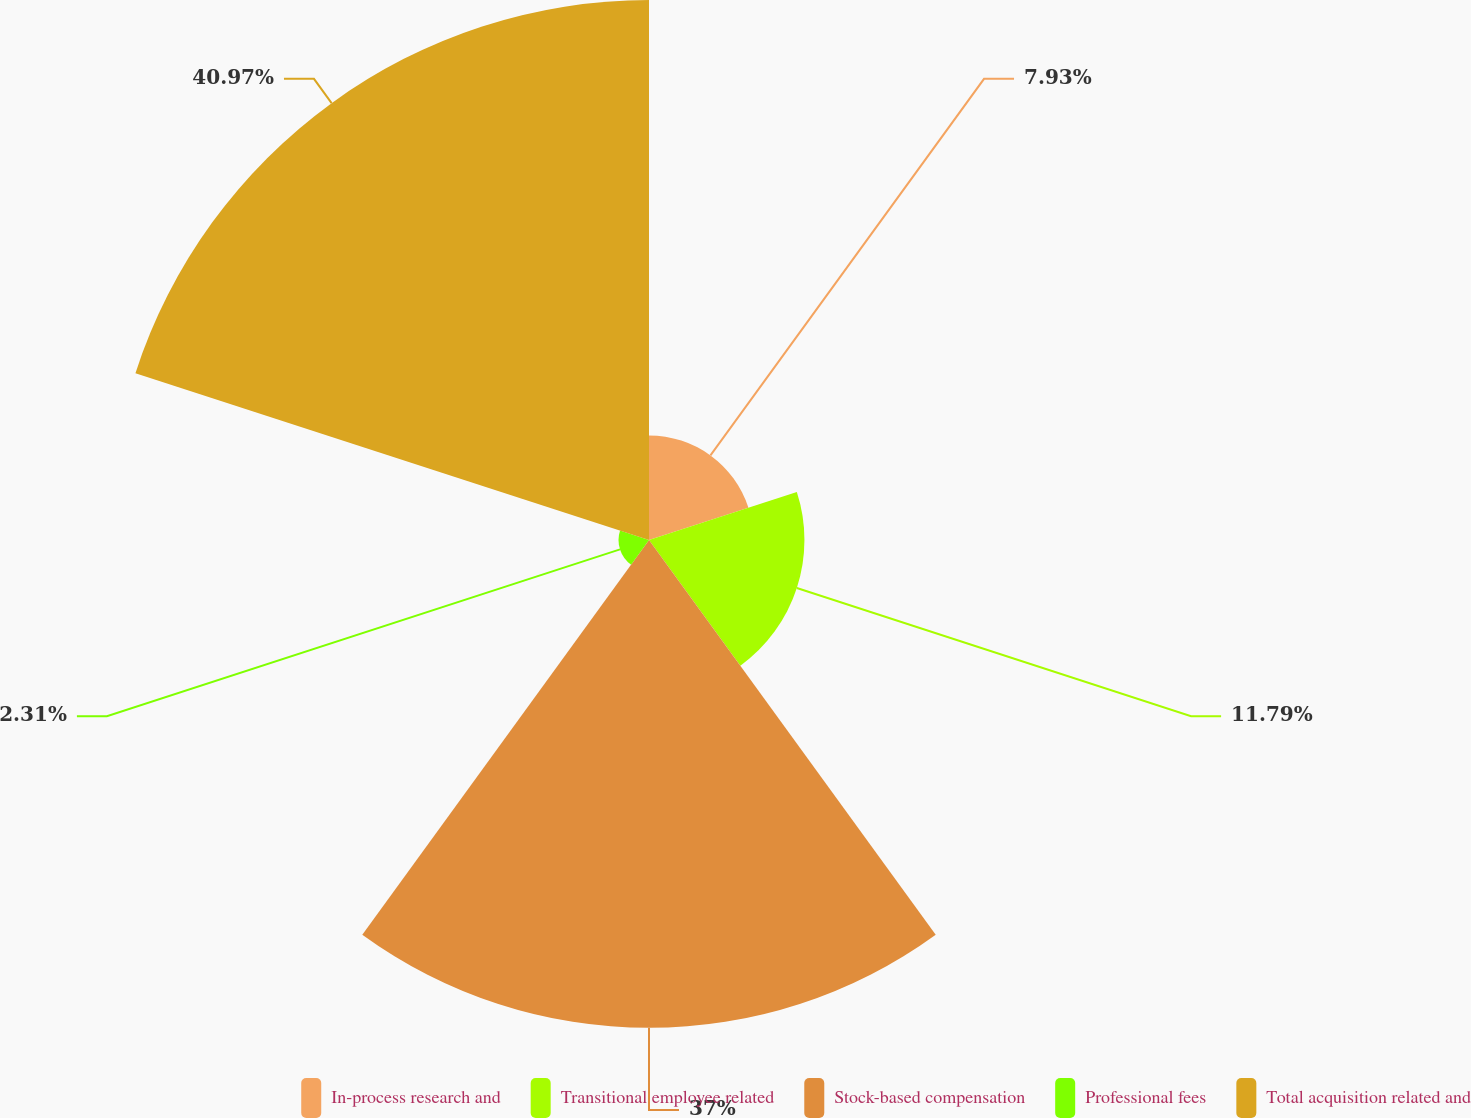<chart> <loc_0><loc_0><loc_500><loc_500><pie_chart><fcel>In-process research and<fcel>Transitional employee related<fcel>Stock-based compensation<fcel>Professional fees<fcel>Total acquisition related and<nl><fcel>7.93%<fcel>11.79%<fcel>37.0%<fcel>2.31%<fcel>40.96%<nl></chart> 